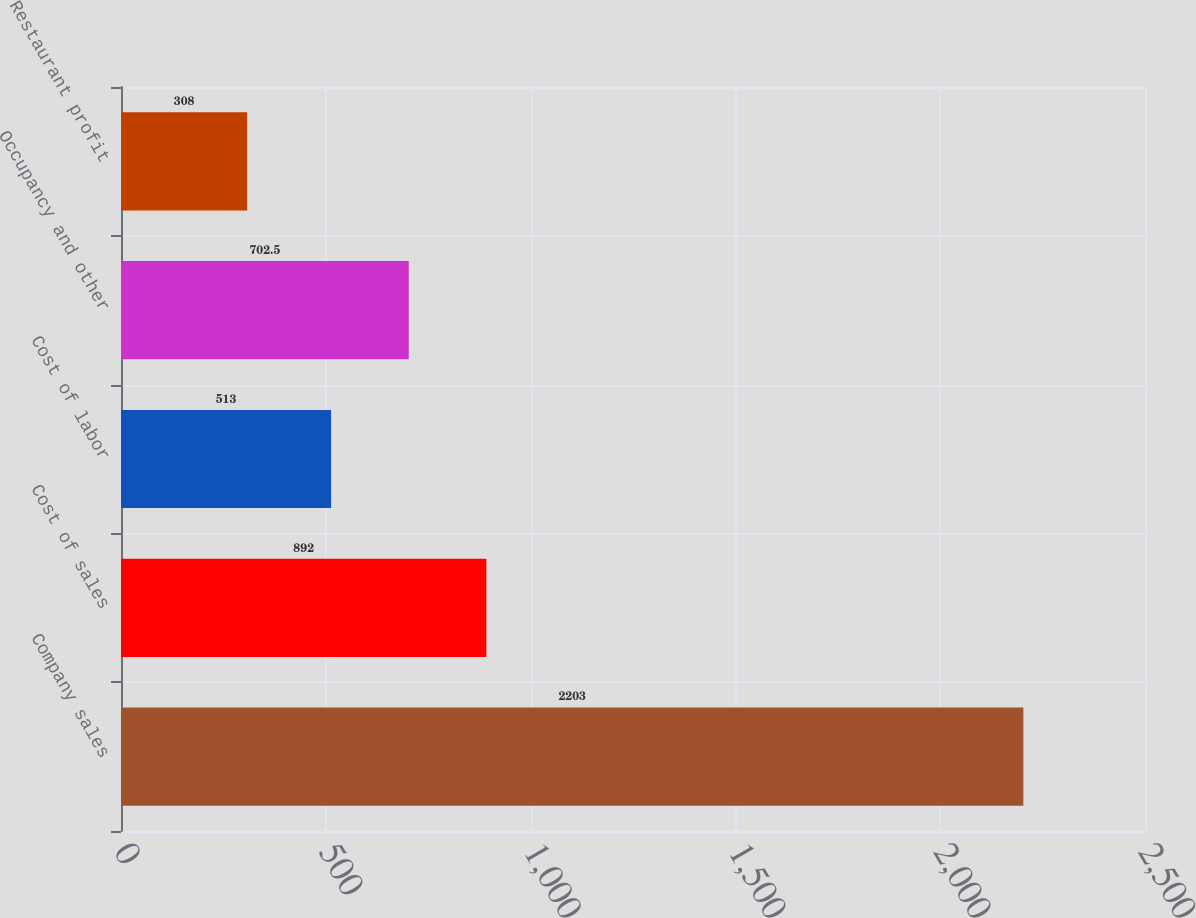Convert chart. <chart><loc_0><loc_0><loc_500><loc_500><bar_chart><fcel>Company sales<fcel>Cost of sales<fcel>Cost of labor<fcel>Occupancy and other<fcel>Restaurant profit<nl><fcel>2203<fcel>892<fcel>513<fcel>702.5<fcel>308<nl></chart> 